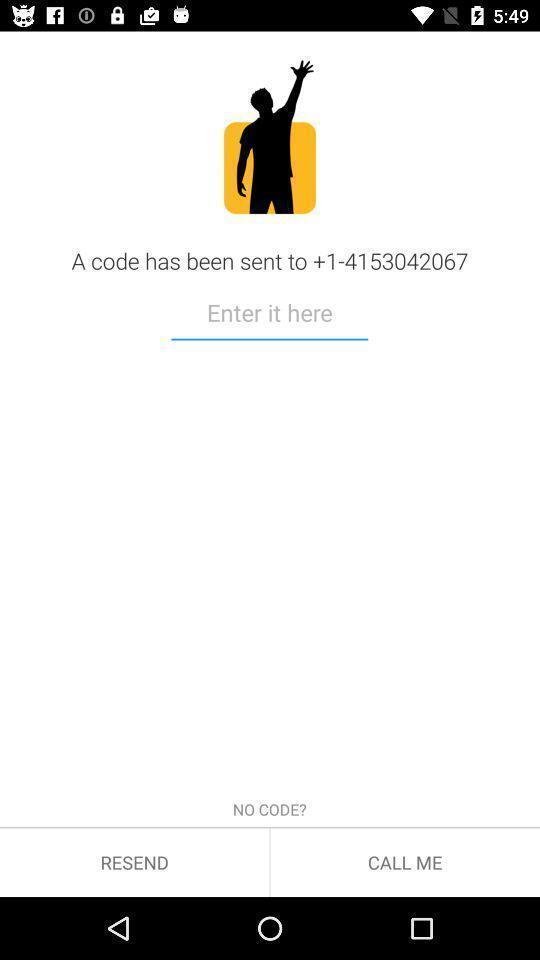Describe this image in words. Page to enter code for using an app. 